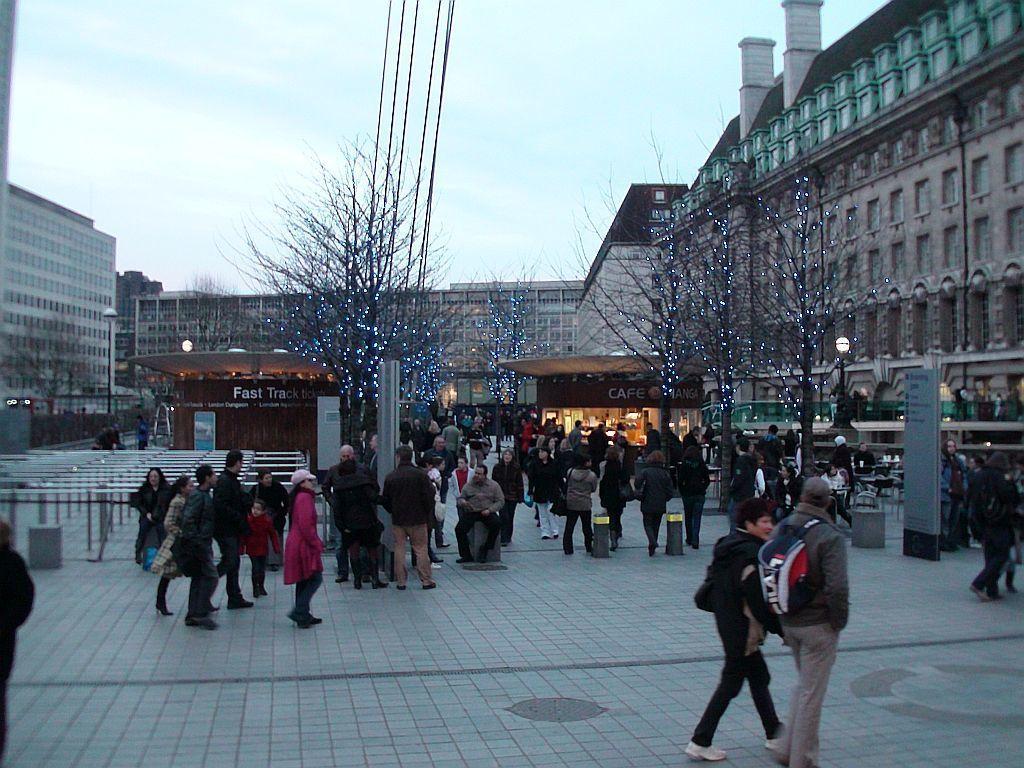How would you summarize this image in a sentence or two? In this image there are people walking on a pavement, in the background there are plants, for that plants there are lights and there are buildings and the sky. 